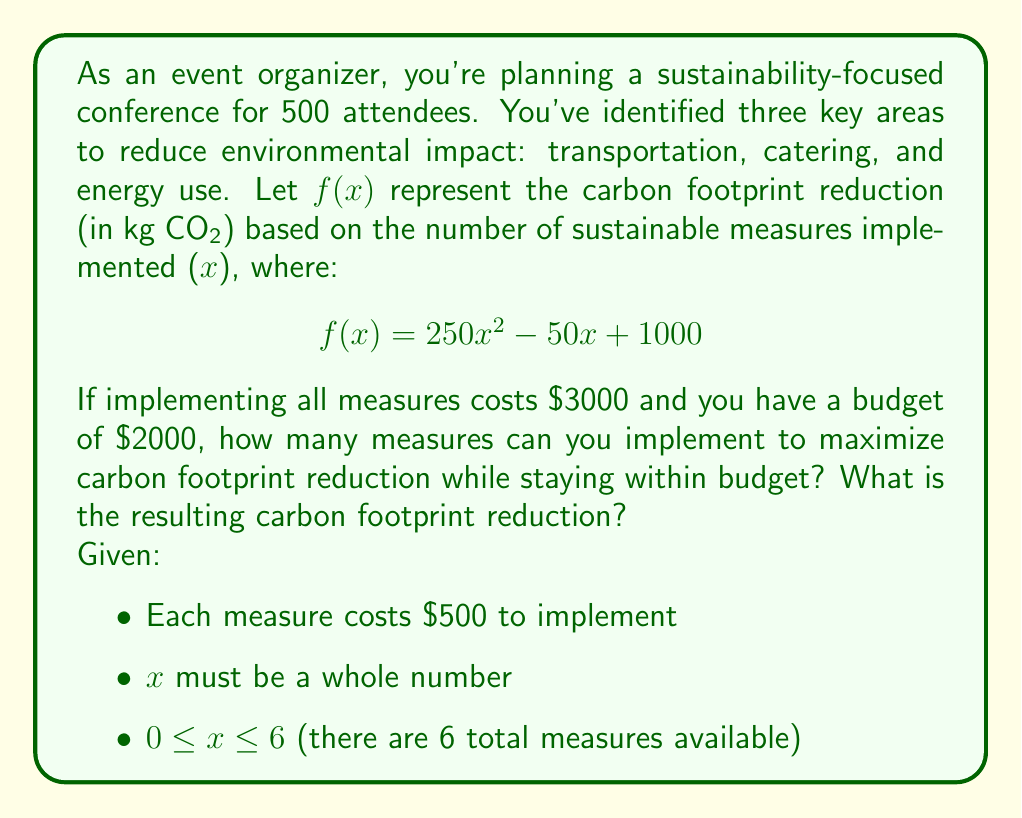What is the answer to this math problem? To solve this problem, we'll follow these steps:

1) First, determine the maximum number of measures that can be implemented within the budget:
   $\$2000 \div \$500 = 4$ measures

2) Now, we need to evaluate $f(x)$ for $x = 0, 1, 2, 3,$ and $4$ to find the maximum reduction:

   For $x = 0$: $f(0) = 250(0)^2 - 50(0) + 1000 = 1000$ kg CO₂
   For $x = 1$: $f(1) = 250(1)^2 - 50(1) + 1000 = 1200$ kg CO₂
   For $x = 2$: $f(2) = 250(2)^2 - 50(2) + 1000 = 1900$ kg CO₂
   For $x = 3$: $f(3) = 250(3)^2 - 50(3) + 1000 = 3100$ kg CO₂
   For $x = 4$: $f(4) = 250(4)^2 - 50(4) + 1000 = 4800$ kg CO₂

3) The maximum reduction occurs when $x = 4$, which is also the maximum number of measures that can be implemented within the budget.

Therefore, implementing 4 measures will maximize the carbon footprint reduction while staying within the $\$2000$ budget, resulting in a reduction of 4800 kg CO₂.
Answer: 4 measures can be implemented, resulting in a carbon footprint reduction of 4800 kg CO₂. 